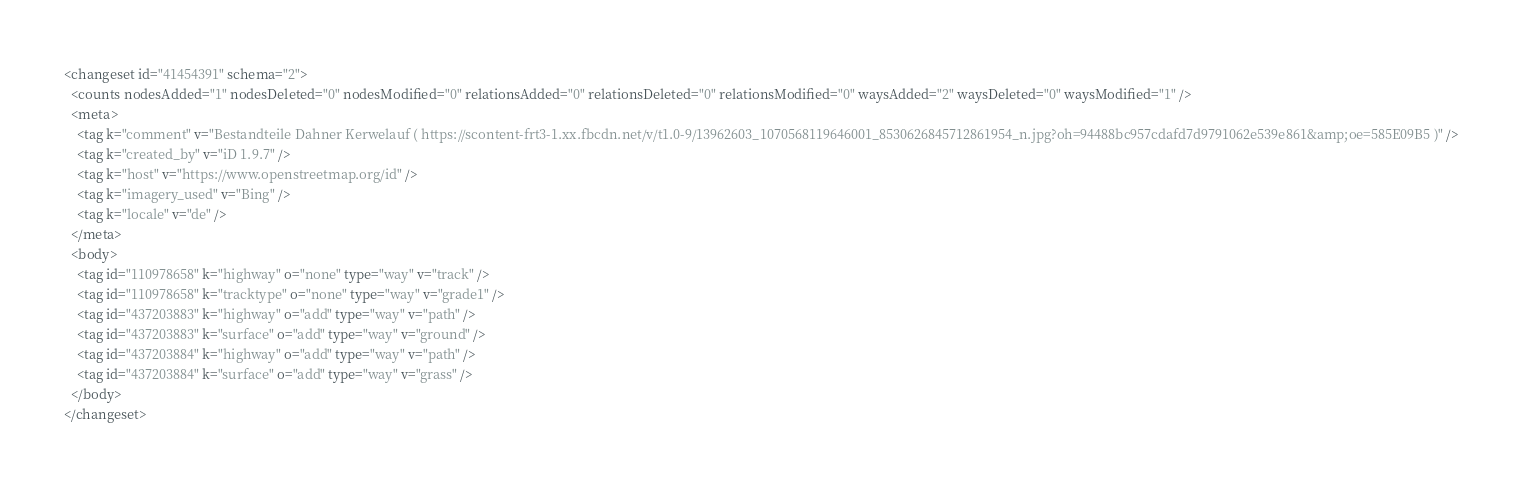<code> <loc_0><loc_0><loc_500><loc_500><_XML_><changeset id="41454391" schema="2">
  <counts nodesAdded="1" nodesDeleted="0" nodesModified="0" relationsAdded="0" relationsDeleted="0" relationsModified="0" waysAdded="2" waysDeleted="0" waysModified="1" />
  <meta>
    <tag k="comment" v="Bestandteile Dahner Kerwelauf ( https://scontent-frt3-1.xx.fbcdn.net/v/t1.0-9/13962603_1070568119646001_8530626845712861954_n.jpg?oh=94488bc957cdafd7d9791062e539e861&amp;oe=585E09B5 )" />
    <tag k="created_by" v="iD 1.9.7" />
    <tag k="host" v="https://www.openstreetmap.org/id" />
    <tag k="imagery_used" v="Bing" />
    <tag k="locale" v="de" />
  </meta>
  <body>
    <tag id="110978658" k="highway" o="none" type="way" v="track" />
    <tag id="110978658" k="tracktype" o="none" type="way" v="grade1" />
    <tag id="437203883" k="highway" o="add" type="way" v="path" />
    <tag id="437203883" k="surface" o="add" type="way" v="ground" />
    <tag id="437203884" k="highway" o="add" type="way" v="path" />
    <tag id="437203884" k="surface" o="add" type="way" v="grass" />
  </body>
</changeset>
</code> 